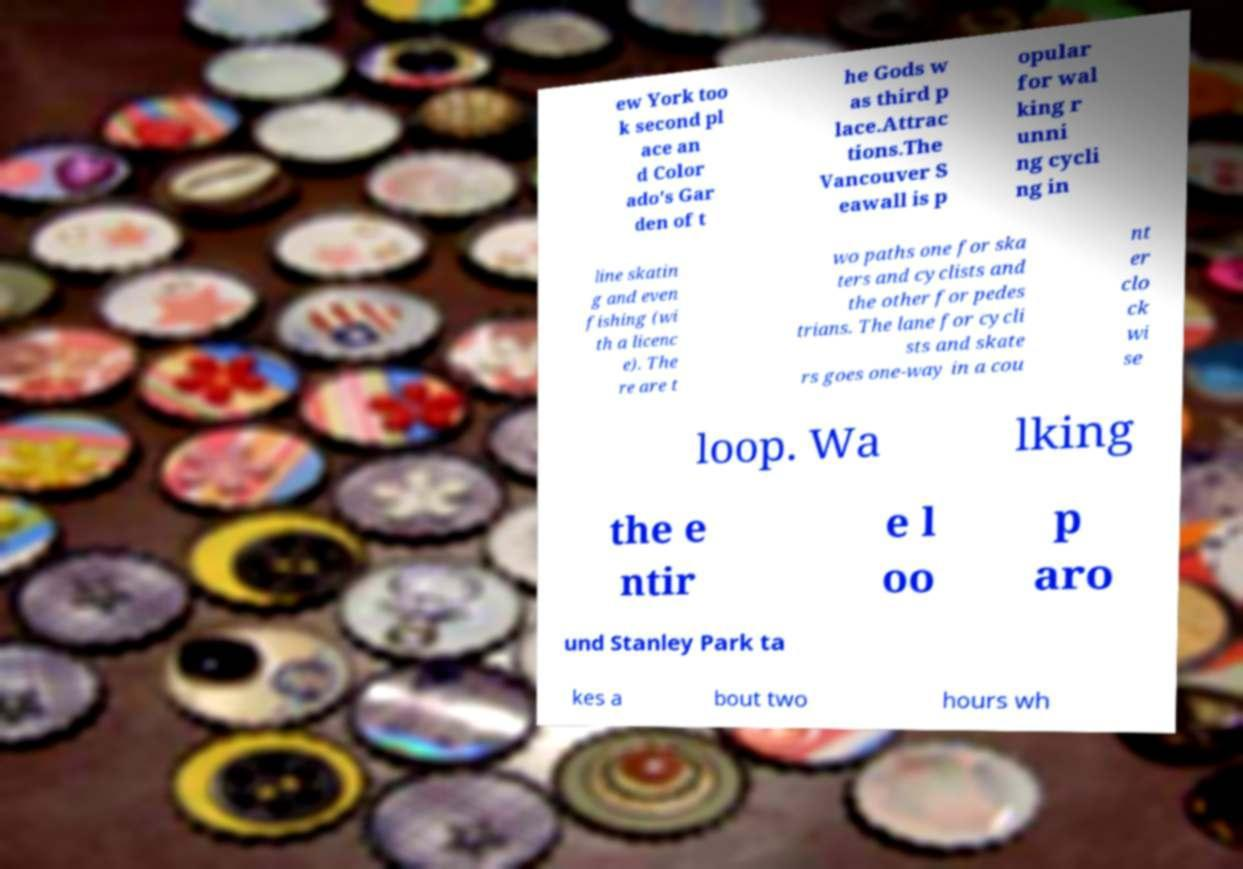Please identify and transcribe the text found in this image. ew York too k second pl ace an d Color ado's Gar den of t he Gods w as third p lace.Attrac tions.The Vancouver S eawall is p opular for wal king r unni ng cycli ng in line skatin g and even fishing (wi th a licenc e). The re are t wo paths one for ska ters and cyclists and the other for pedes trians. The lane for cycli sts and skate rs goes one-way in a cou nt er clo ck wi se loop. Wa lking the e ntir e l oo p aro und Stanley Park ta kes a bout two hours wh 